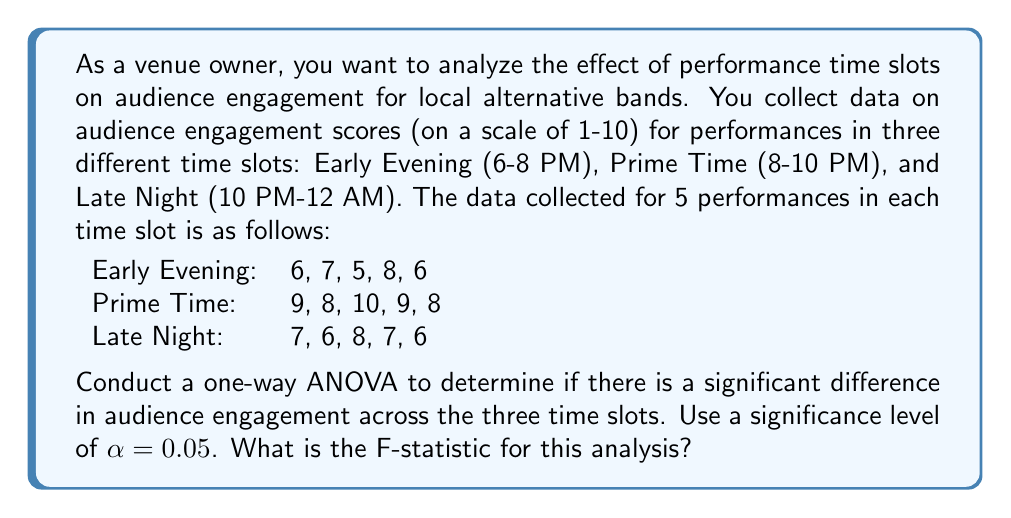Can you answer this question? To conduct a one-way ANOVA, we need to follow these steps:

1. Calculate the sum of squares between groups (SSB)
2. Calculate the sum of squares within groups (SSW)
3. Calculate the total sum of squares (SST)
4. Calculate the degrees of freedom (df)
5. Calculate the mean squares
6. Calculate the F-statistic

Step 1: Calculate SSB

First, we need to calculate the grand mean and the means for each group:

Grand mean: $\bar{X} = \frac{6+7+5+8+6+9+8+10+9+8+7+6+8+7+6}{15} = 7.33$

Early Evening mean: $\bar{X}_1 = \frac{6+7+5+8+6}{5} = 6.4$
Prime Time mean: $\bar{X}_2 = \frac{9+8+10+9+8}{5} = 8.8$
Late Night mean: $\bar{X}_3 = \frac{7+6+8+7+6}{5} = 6.8$

Now, we can calculate SSB:

$$SSB = n_1(\bar{X}_1 - \bar{X})^2 + n_2(\bar{X}_2 - \bar{X})^2 + n_3(\bar{X}_3 - \bar{X})^2$$
$$SSB = 5(6.4 - 7.33)^2 + 5(8.8 - 7.33)^2 + 5(6.8 - 7.33)^2$$
$$SSB = 5(0.93^2) + 5(1.47^2) + 5(0.53^2)$$
$$SSB = 4.3245 + 10.8045 + 1.4045 = 16.5335$$

Step 2: Calculate SSW

$$SSW = \sum_{i=1}^{3}\sum_{j=1}^{5}(X_{ij} - \bar{X}_i)^2$$

For Early Evening: $(6-6.4)^2 + (7-6.4)^2 + (5-6.4)^2 + (8-6.4)^2 + (6-6.4)^2 = 5.2$
For Prime Time: $(9-8.8)^2 + (8-8.8)^2 + (10-8.8)^2 + (9-8.8)^2 + (8-8.8)^2 = 2.8$
For Late Night: $(7-6.8)^2 + (6-6.8)^2 + (8-6.8)^2 + (7-6.8)^2 + (6-6.8)^2 = 2.8$

$$SSW = 5.2 + 2.8 + 2.8 = 10.8$$

Step 3: Calculate SST

$$SST = SSB + SSW = 16.5335 + 10.8 = 27.3335$$

Step 4: Calculate degrees of freedom

df between groups = k - 1 = 3 - 1 = 2
df within groups = N - k = 15 - 3 = 12
df total = N - 1 = 15 - 1 = 14

Step 5: Calculate mean squares

$$MSB = \frac{SSB}{df_{between}} = \frac{16.5335}{2} = 8.26675$$
$$MSW = \frac{SSW}{df_{within}} = \frac{10.8}{12} = 0.9$$

Step 6: Calculate F-statistic

$$F = \frac{MSB}{MSW} = \frac{8.26675}{0.9} = 9.1853$$
Answer: The F-statistic for this analysis is approximately 9.1853. 